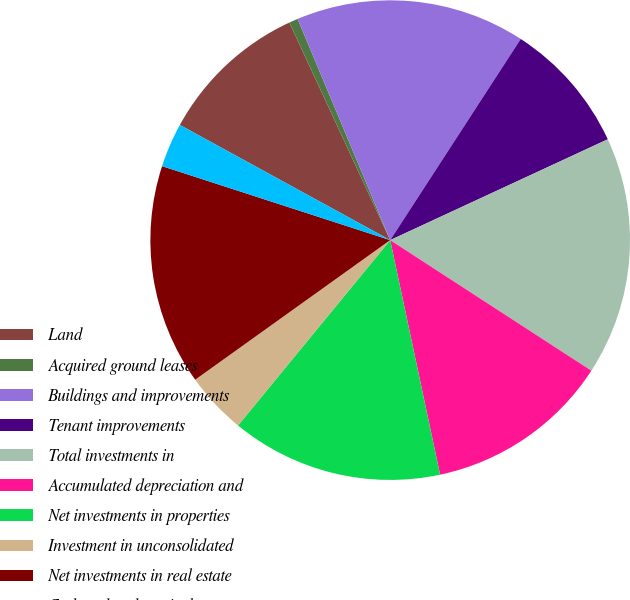Convert chart. <chart><loc_0><loc_0><loc_500><loc_500><pie_chart><fcel>Land<fcel>Acquired ground leases<fcel>Buildings and improvements<fcel>Tenant improvements<fcel>Total investments in<fcel>Accumulated depreciation and<fcel>Net investments in properties<fcel>Investment in unconsolidated<fcel>Net investments in real estate<fcel>Cash and cash equivalents<nl><fcel>10.12%<fcel>0.6%<fcel>15.47%<fcel>8.93%<fcel>16.07%<fcel>12.5%<fcel>14.28%<fcel>4.17%<fcel>14.88%<fcel>2.98%<nl></chart> 